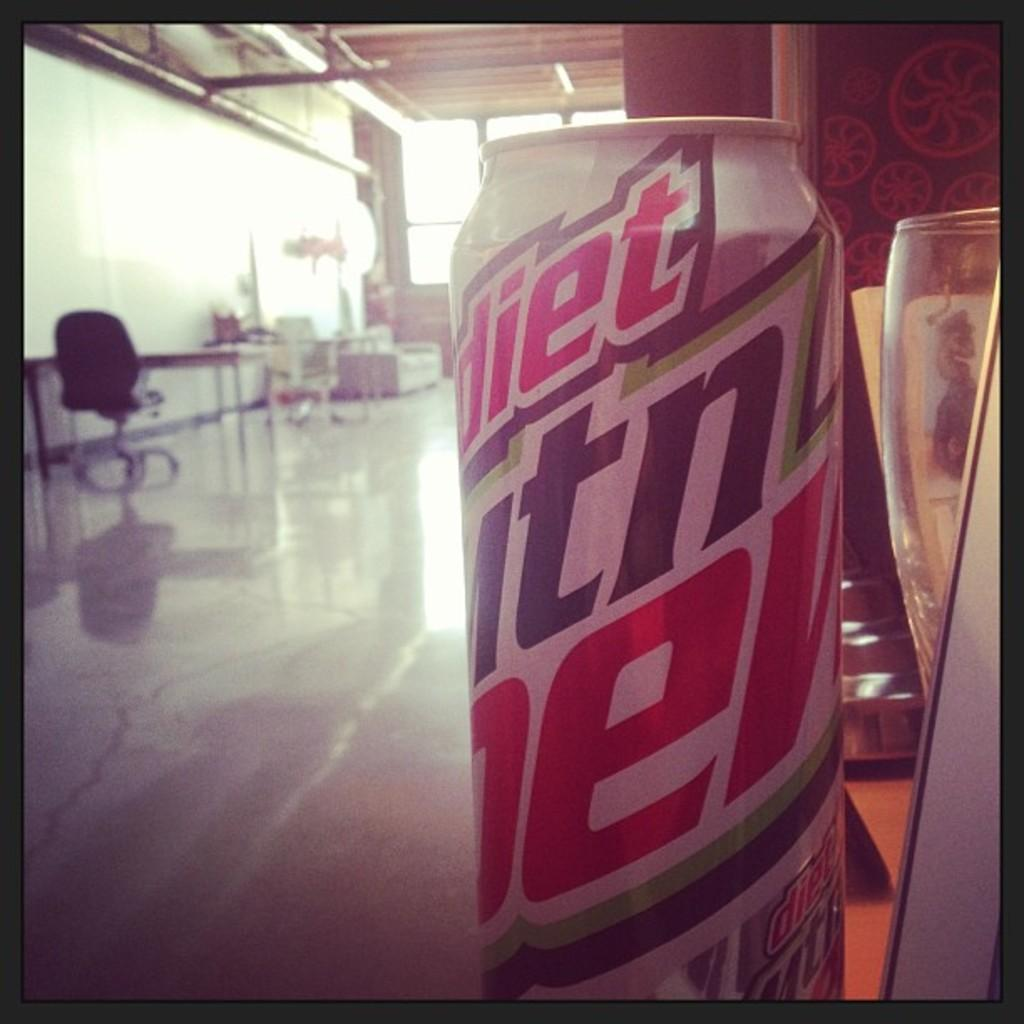<image>
Create a compact narrative representing the image presented. A can of Diet Mountain Dew with a room in the background. 